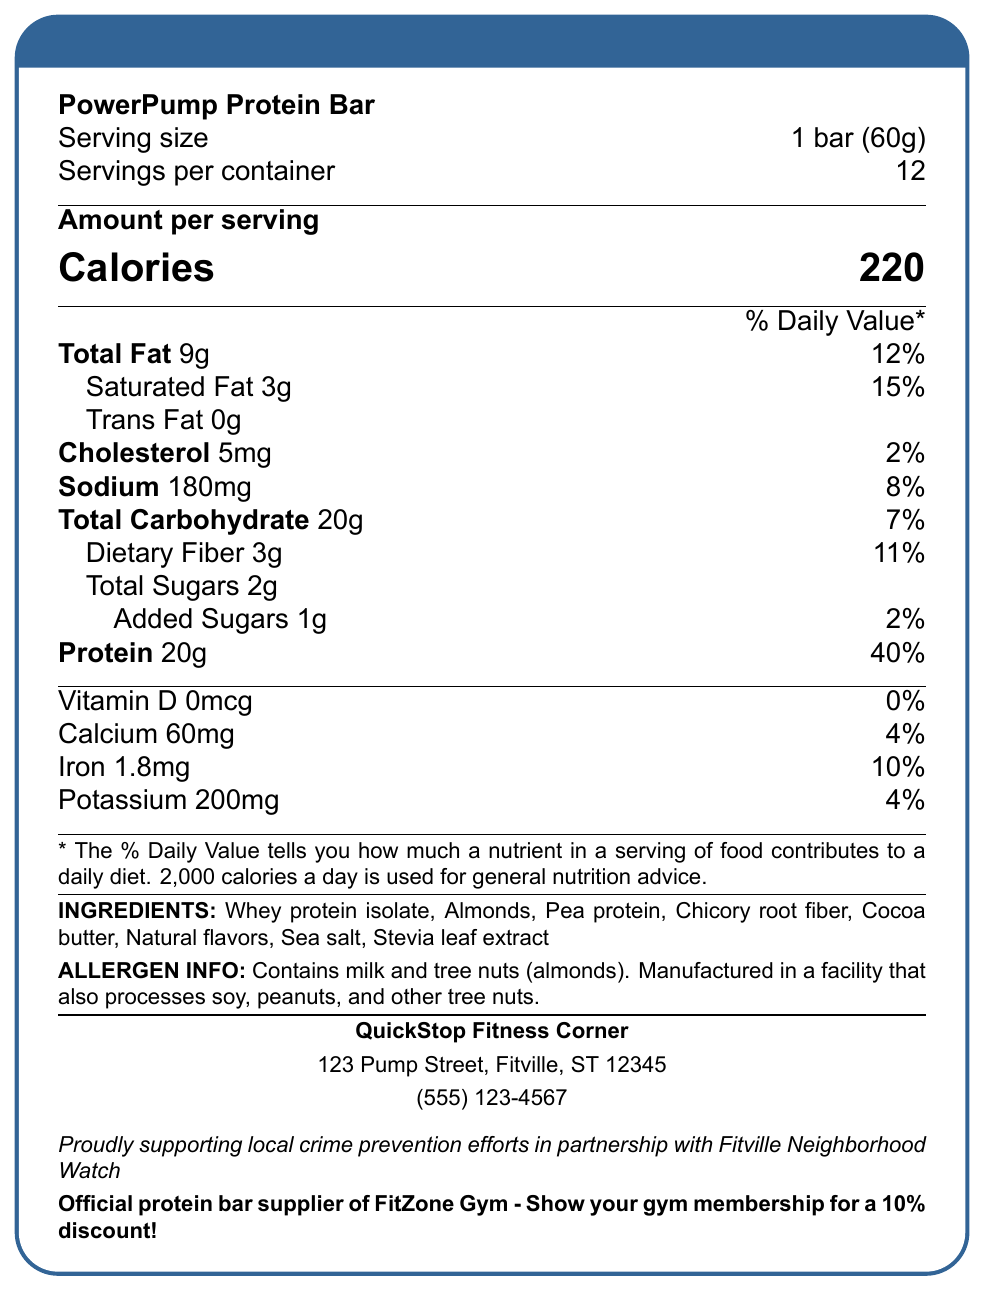what is the product name? The product name is clearly stated at the beginning of the document.
Answer: PowerPump Protein Bar how many servings are in one container? The document specifies that there are 12 servings per container.
Answer: 12 how many grams of protein are in one serving? The document lists the protein content as 20 grams per serving.
Answer: 20g what is the serving size? The document indicates that the serving size is 1 bar, which weighs 60 grams.
Answer: 1 bar (60g) what are the main ingredients of the PowerPump Protein Bar? The ingredients are listed towards the end of the document.
Answer: Whey protein isolate, Almonds, Pea protein, Chicory root fiber, Cocoa butter, Natural flavors, Sea salt, Stevia leaf extract what percentage of the daily value of saturated fat is in one serving? The document shows that one serving contains 15% of the daily value of saturated fat.
Answer: 15% which gym offers a discount for showing a gym membership? A. FlexGym B. MuscleHub C. FitZone Gym D. PowerHouse The document specifies that FitZone Gym offers a 10% discount for showing a gym membership.
Answer: C. FitZone Gym how many calories are there in one serving? A. 180 B. 220 C. 200 D. 250 The document states that there are 220 calories per serving.
Answer: B. 220 is the PowerPump Protein Bar allergen-free? The allergen information section indicates that the bar contains milk and tree nuts (almonds) and is manufactured in a facility that processes soy, peanuts, and other tree nuts.
Answer: No does the PowerPump Protein Bar contain any added sugars? The document lists 1g of added sugars per serving.
Answer: Yes what vitamins and minerals are included in the PowerPump Protein Bar? The document details the amounts of Vitamin D, Calcium, Iron, and Potassium included in the bar.
Answer: Vitamin D, Calcium, Iron, Potassium where is QuickStop Fitness Corner located? The store's address is given at the bottom of the document.
Answer: 123 Pump Street, Fitville, ST 12345 is the PowerPump Protein Bar high in protein? The document shows that each bar contains 20g of protein, which is 40% of the daily value, indicating it is high in protein.
Answer: Yes summarize the main idea of the document. The document is focused on delivering key nutritional information about the PowerPump Protein Bar while emphasizing its high protein and low carbohydrate content, making it suitable for gym-goers. It also promotes store and gym partnerships and provides allergen information.
Answer: The document provides the nutrition facts, ingredients, and allergen information for the PowerPump Protein Bar, a high-protein, low-carbohydrate snack targeted at gym-goers. It also includes details about store location, partnerships, and discounts. how many grams of dietary fiber are in each serving? The document lists that each serving contains 3 grams of dietary fiber.
Answer: 3g what is the daily value percentage of iron in one serving? The nutritional information specifies that one serving contains 10% of the daily value of iron.
Answer: 10% is this product suitable for someone avoiding tree nuts? The allergen information states that the product contains tree nuts (almonds).
Answer: No what activities does QuickStop Fitness Corner support? The document mentions that the store supports local crime prevention efforts in partnership with the Fitville Neighborhood Watch.
Answer: Local crime prevention efforts in partnership with Fitville Neighborhood Watch which ingredient is not listed in the PowerPump Protein Bar? The question asks for information that is not visually available in the document as it does not list ingredients that are not included. Only listed ingredients are provided.
Answer: Cannot be determined 